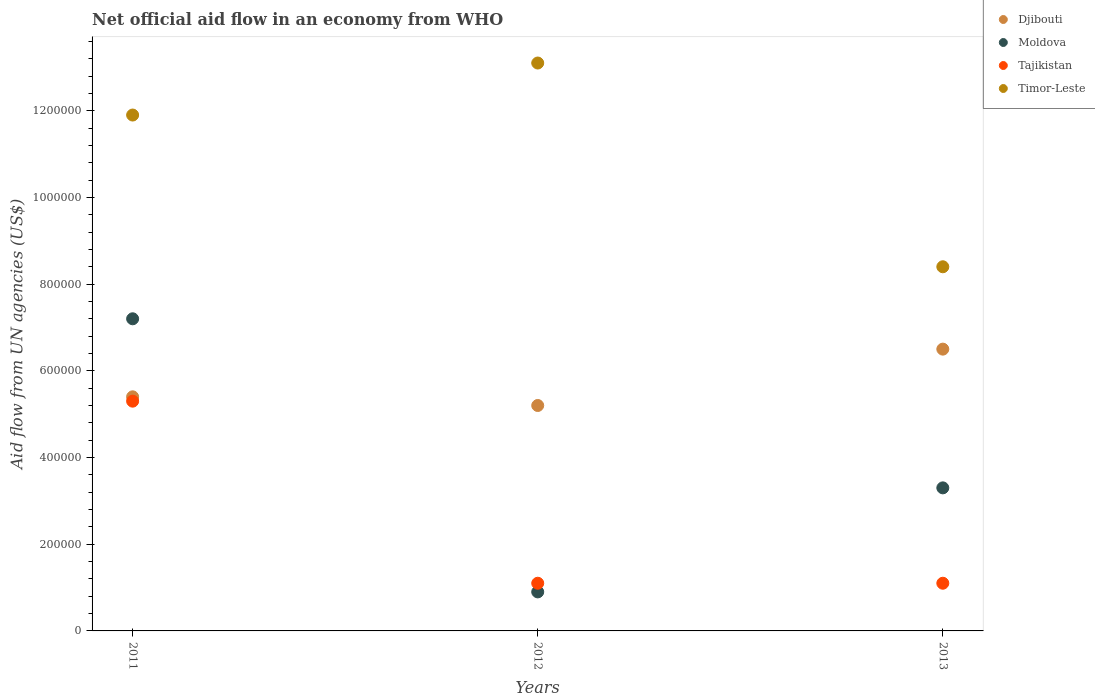Is the number of dotlines equal to the number of legend labels?
Make the answer very short. Yes. Across all years, what is the maximum net official aid flow in Timor-Leste?
Offer a terse response. 1.31e+06. Across all years, what is the minimum net official aid flow in Timor-Leste?
Ensure brevity in your answer.  8.40e+05. In which year was the net official aid flow in Djibouti minimum?
Make the answer very short. 2012. What is the total net official aid flow in Timor-Leste in the graph?
Give a very brief answer. 3.34e+06. What is the difference between the net official aid flow in Tajikistan in 2011 and that in 2012?
Give a very brief answer. 4.20e+05. What is the difference between the net official aid flow in Djibouti in 2013 and the net official aid flow in Tajikistan in 2012?
Ensure brevity in your answer.  5.40e+05. In the year 2013, what is the difference between the net official aid flow in Moldova and net official aid flow in Djibouti?
Ensure brevity in your answer.  -3.20e+05. What is the ratio of the net official aid flow in Timor-Leste in 2011 to that in 2012?
Provide a succinct answer. 0.91. Is the net official aid flow in Tajikistan in 2011 less than that in 2012?
Give a very brief answer. No. Is the difference between the net official aid flow in Moldova in 2012 and 2013 greater than the difference between the net official aid flow in Djibouti in 2012 and 2013?
Your answer should be compact. No. What is the difference between the highest and the lowest net official aid flow in Djibouti?
Offer a very short reply. 1.30e+05. In how many years, is the net official aid flow in Timor-Leste greater than the average net official aid flow in Timor-Leste taken over all years?
Ensure brevity in your answer.  2. Is the sum of the net official aid flow in Moldova in 2011 and 2013 greater than the maximum net official aid flow in Timor-Leste across all years?
Your answer should be compact. No. Is it the case that in every year, the sum of the net official aid flow in Timor-Leste and net official aid flow in Tajikistan  is greater than the sum of net official aid flow in Djibouti and net official aid flow in Moldova?
Keep it short and to the point. No. Is it the case that in every year, the sum of the net official aid flow in Moldova and net official aid flow in Timor-Leste  is greater than the net official aid flow in Tajikistan?
Give a very brief answer. Yes. Is the net official aid flow in Timor-Leste strictly greater than the net official aid flow in Moldova over the years?
Ensure brevity in your answer.  Yes. How many years are there in the graph?
Make the answer very short. 3. What is the difference between two consecutive major ticks on the Y-axis?
Keep it short and to the point. 2.00e+05. What is the title of the graph?
Provide a short and direct response. Net official aid flow in an economy from WHO. Does "Lebanon" appear as one of the legend labels in the graph?
Your answer should be compact. No. What is the label or title of the Y-axis?
Give a very brief answer. Aid flow from UN agencies (US$). What is the Aid flow from UN agencies (US$) in Djibouti in 2011?
Offer a very short reply. 5.40e+05. What is the Aid flow from UN agencies (US$) in Moldova in 2011?
Offer a very short reply. 7.20e+05. What is the Aid flow from UN agencies (US$) in Tajikistan in 2011?
Offer a terse response. 5.30e+05. What is the Aid flow from UN agencies (US$) in Timor-Leste in 2011?
Give a very brief answer. 1.19e+06. What is the Aid flow from UN agencies (US$) of Djibouti in 2012?
Your answer should be compact. 5.20e+05. What is the Aid flow from UN agencies (US$) in Moldova in 2012?
Provide a succinct answer. 9.00e+04. What is the Aid flow from UN agencies (US$) in Tajikistan in 2012?
Your answer should be very brief. 1.10e+05. What is the Aid flow from UN agencies (US$) of Timor-Leste in 2012?
Ensure brevity in your answer.  1.31e+06. What is the Aid flow from UN agencies (US$) of Djibouti in 2013?
Your response must be concise. 6.50e+05. What is the Aid flow from UN agencies (US$) in Moldova in 2013?
Ensure brevity in your answer.  3.30e+05. What is the Aid flow from UN agencies (US$) of Tajikistan in 2013?
Provide a succinct answer. 1.10e+05. What is the Aid flow from UN agencies (US$) of Timor-Leste in 2013?
Give a very brief answer. 8.40e+05. Across all years, what is the maximum Aid flow from UN agencies (US$) of Djibouti?
Your answer should be compact. 6.50e+05. Across all years, what is the maximum Aid flow from UN agencies (US$) in Moldova?
Ensure brevity in your answer.  7.20e+05. Across all years, what is the maximum Aid flow from UN agencies (US$) of Tajikistan?
Ensure brevity in your answer.  5.30e+05. Across all years, what is the maximum Aid flow from UN agencies (US$) of Timor-Leste?
Your answer should be very brief. 1.31e+06. Across all years, what is the minimum Aid flow from UN agencies (US$) of Djibouti?
Keep it short and to the point. 5.20e+05. Across all years, what is the minimum Aid flow from UN agencies (US$) in Moldova?
Ensure brevity in your answer.  9.00e+04. Across all years, what is the minimum Aid flow from UN agencies (US$) of Timor-Leste?
Make the answer very short. 8.40e+05. What is the total Aid flow from UN agencies (US$) of Djibouti in the graph?
Your answer should be compact. 1.71e+06. What is the total Aid flow from UN agencies (US$) of Moldova in the graph?
Offer a very short reply. 1.14e+06. What is the total Aid flow from UN agencies (US$) of Tajikistan in the graph?
Your response must be concise. 7.50e+05. What is the total Aid flow from UN agencies (US$) in Timor-Leste in the graph?
Your answer should be compact. 3.34e+06. What is the difference between the Aid flow from UN agencies (US$) in Djibouti in 2011 and that in 2012?
Offer a terse response. 2.00e+04. What is the difference between the Aid flow from UN agencies (US$) in Moldova in 2011 and that in 2012?
Ensure brevity in your answer.  6.30e+05. What is the difference between the Aid flow from UN agencies (US$) of Moldova in 2011 and that in 2013?
Your answer should be very brief. 3.90e+05. What is the difference between the Aid flow from UN agencies (US$) in Timor-Leste in 2012 and that in 2013?
Make the answer very short. 4.70e+05. What is the difference between the Aid flow from UN agencies (US$) of Djibouti in 2011 and the Aid flow from UN agencies (US$) of Moldova in 2012?
Make the answer very short. 4.50e+05. What is the difference between the Aid flow from UN agencies (US$) in Djibouti in 2011 and the Aid flow from UN agencies (US$) in Timor-Leste in 2012?
Your response must be concise. -7.70e+05. What is the difference between the Aid flow from UN agencies (US$) of Moldova in 2011 and the Aid flow from UN agencies (US$) of Tajikistan in 2012?
Your answer should be compact. 6.10e+05. What is the difference between the Aid flow from UN agencies (US$) in Moldova in 2011 and the Aid flow from UN agencies (US$) in Timor-Leste in 2012?
Offer a very short reply. -5.90e+05. What is the difference between the Aid flow from UN agencies (US$) in Tajikistan in 2011 and the Aid flow from UN agencies (US$) in Timor-Leste in 2012?
Keep it short and to the point. -7.80e+05. What is the difference between the Aid flow from UN agencies (US$) of Djibouti in 2011 and the Aid flow from UN agencies (US$) of Moldova in 2013?
Offer a very short reply. 2.10e+05. What is the difference between the Aid flow from UN agencies (US$) in Djibouti in 2011 and the Aid flow from UN agencies (US$) in Timor-Leste in 2013?
Keep it short and to the point. -3.00e+05. What is the difference between the Aid flow from UN agencies (US$) of Moldova in 2011 and the Aid flow from UN agencies (US$) of Tajikistan in 2013?
Offer a very short reply. 6.10e+05. What is the difference between the Aid flow from UN agencies (US$) of Tajikistan in 2011 and the Aid flow from UN agencies (US$) of Timor-Leste in 2013?
Provide a short and direct response. -3.10e+05. What is the difference between the Aid flow from UN agencies (US$) in Djibouti in 2012 and the Aid flow from UN agencies (US$) in Tajikistan in 2013?
Keep it short and to the point. 4.10e+05. What is the difference between the Aid flow from UN agencies (US$) in Djibouti in 2012 and the Aid flow from UN agencies (US$) in Timor-Leste in 2013?
Your answer should be very brief. -3.20e+05. What is the difference between the Aid flow from UN agencies (US$) in Moldova in 2012 and the Aid flow from UN agencies (US$) in Timor-Leste in 2013?
Ensure brevity in your answer.  -7.50e+05. What is the difference between the Aid flow from UN agencies (US$) in Tajikistan in 2012 and the Aid flow from UN agencies (US$) in Timor-Leste in 2013?
Make the answer very short. -7.30e+05. What is the average Aid flow from UN agencies (US$) in Djibouti per year?
Provide a succinct answer. 5.70e+05. What is the average Aid flow from UN agencies (US$) of Moldova per year?
Keep it short and to the point. 3.80e+05. What is the average Aid flow from UN agencies (US$) of Timor-Leste per year?
Offer a very short reply. 1.11e+06. In the year 2011, what is the difference between the Aid flow from UN agencies (US$) in Djibouti and Aid flow from UN agencies (US$) in Timor-Leste?
Offer a very short reply. -6.50e+05. In the year 2011, what is the difference between the Aid flow from UN agencies (US$) of Moldova and Aid flow from UN agencies (US$) of Timor-Leste?
Your answer should be compact. -4.70e+05. In the year 2011, what is the difference between the Aid flow from UN agencies (US$) in Tajikistan and Aid flow from UN agencies (US$) in Timor-Leste?
Offer a terse response. -6.60e+05. In the year 2012, what is the difference between the Aid flow from UN agencies (US$) of Djibouti and Aid flow from UN agencies (US$) of Timor-Leste?
Offer a terse response. -7.90e+05. In the year 2012, what is the difference between the Aid flow from UN agencies (US$) in Moldova and Aid flow from UN agencies (US$) in Timor-Leste?
Make the answer very short. -1.22e+06. In the year 2012, what is the difference between the Aid flow from UN agencies (US$) of Tajikistan and Aid flow from UN agencies (US$) of Timor-Leste?
Ensure brevity in your answer.  -1.20e+06. In the year 2013, what is the difference between the Aid flow from UN agencies (US$) of Djibouti and Aid flow from UN agencies (US$) of Moldova?
Offer a very short reply. 3.20e+05. In the year 2013, what is the difference between the Aid flow from UN agencies (US$) in Djibouti and Aid flow from UN agencies (US$) in Tajikistan?
Provide a short and direct response. 5.40e+05. In the year 2013, what is the difference between the Aid flow from UN agencies (US$) of Moldova and Aid flow from UN agencies (US$) of Timor-Leste?
Give a very brief answer. -5.10e+05. In the year 2013, what is the difference between the Aid flow from UN agencies (US$) in Tajikistan and Aid flow from UN agencies (US$) in Timor-Leste?
Offer a very short reply. -7.30e+05. What is the ratio of the Aid flow from UN agencies (US$) in Moldova in 2011 to that in 2012?
Offer a terse response. 8. What is the ratio of the Aid flow from UN agencies (US$) in Tajikistan in 2011 to that in 2012?
Your answer should be very brief. 4.82. What is the ratio of the Aid flow from UN agencies (US$) of Timor-Leste in 2011 to that in 2012?
Offer a very short reply. 0.91. What is the ratio of the Aid flow from UN agencies (US$) of Djibouti in 2011 to that in 2013?
Give a very brief answer. 0.83. What is the ratio of the Aid flow from UN agencies (US$) of Moldova in 2011 to that in 2013?
Ensure brevity in your answer.  2.18. What is the ratio of the Aid flow from UN agencies (US$) of Tajikistan in 2011 to that in 2013?
Offer a very short reply. 4.82. What is the ratio of the Aid flow from UN agencies (US$) of Timor-Leste in 2011 to that in 2013?
Provide a succinct answer. 1.42. What is the ratio of the Aid flow from UN agencies (US$) in Moldova in 2012 to that in 2013?
Provide a succinct answer. 0.27. What is the ratio of the Aid flow from UN agencies (US$) in Timor-Leste in 2012 to that in 2013?
Offer a terse response. 1.56. What is the difference between the highest and the second highest Aid flow from UN agencies (US$) of Tajikistan?
Provide a short and direct response. 4.20e+05. What is the difference between the highest and the lowest Aid flow from UN agencies (US$) in Djibouti?
Keep it short and to the point. 1.30e+05. What is the difference between the highest and the lowest Aid flow from UN agencies (US$) of Moldova?
Provide a short and direct response. 6.30e+05. What is the difference between the highest and the lowest Aid flow from UN agencies (US$) in Tajikistan?
Make the answer very short. 4.20e+05. 